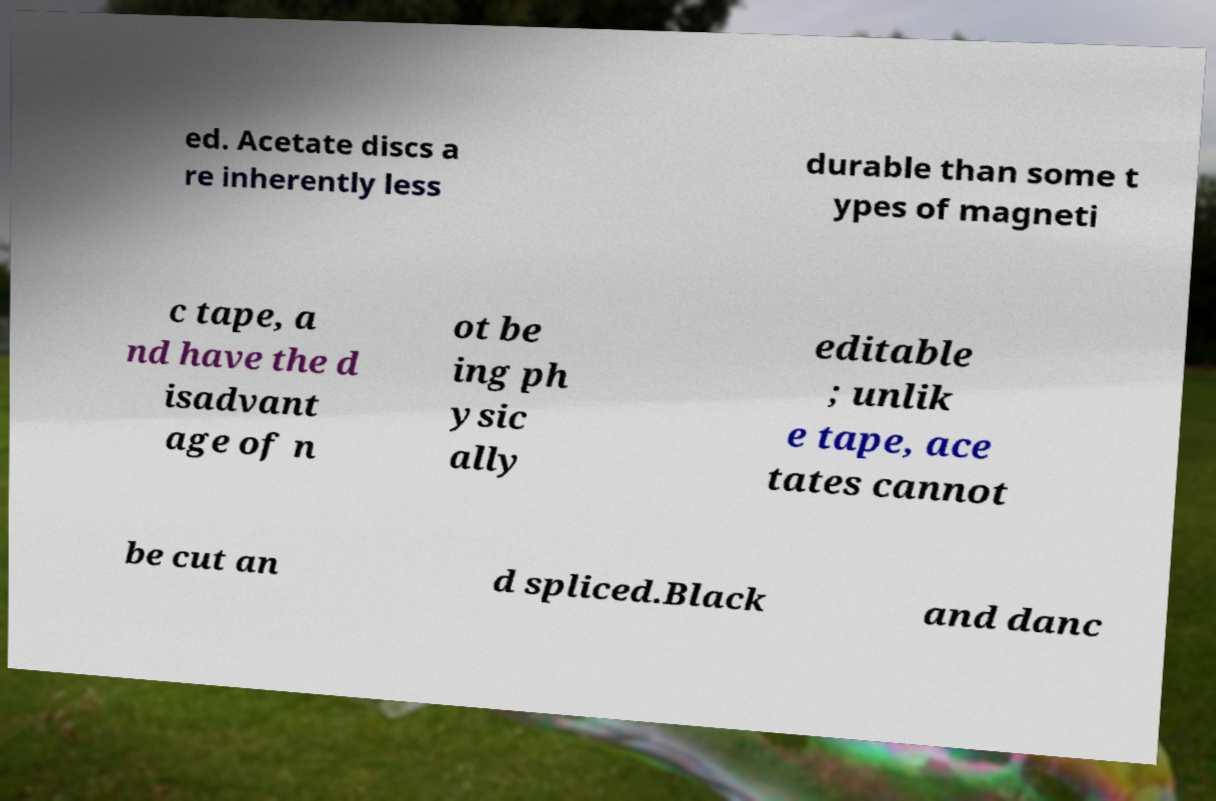What messages or text are displayed in this image? I need them in a readable, typed format. ed. Acetate discs a re inherently less durable than some t ypes of magneti c tape, a nd have the d isadvant age of n ot be ing ph ysic ally editable ; unlik e tape, ace tates cannot be cut an d spliced.Black and danc 